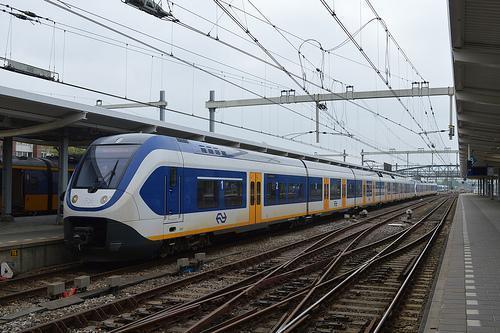How many tracks are there?
Give a very brief answer. 3. 